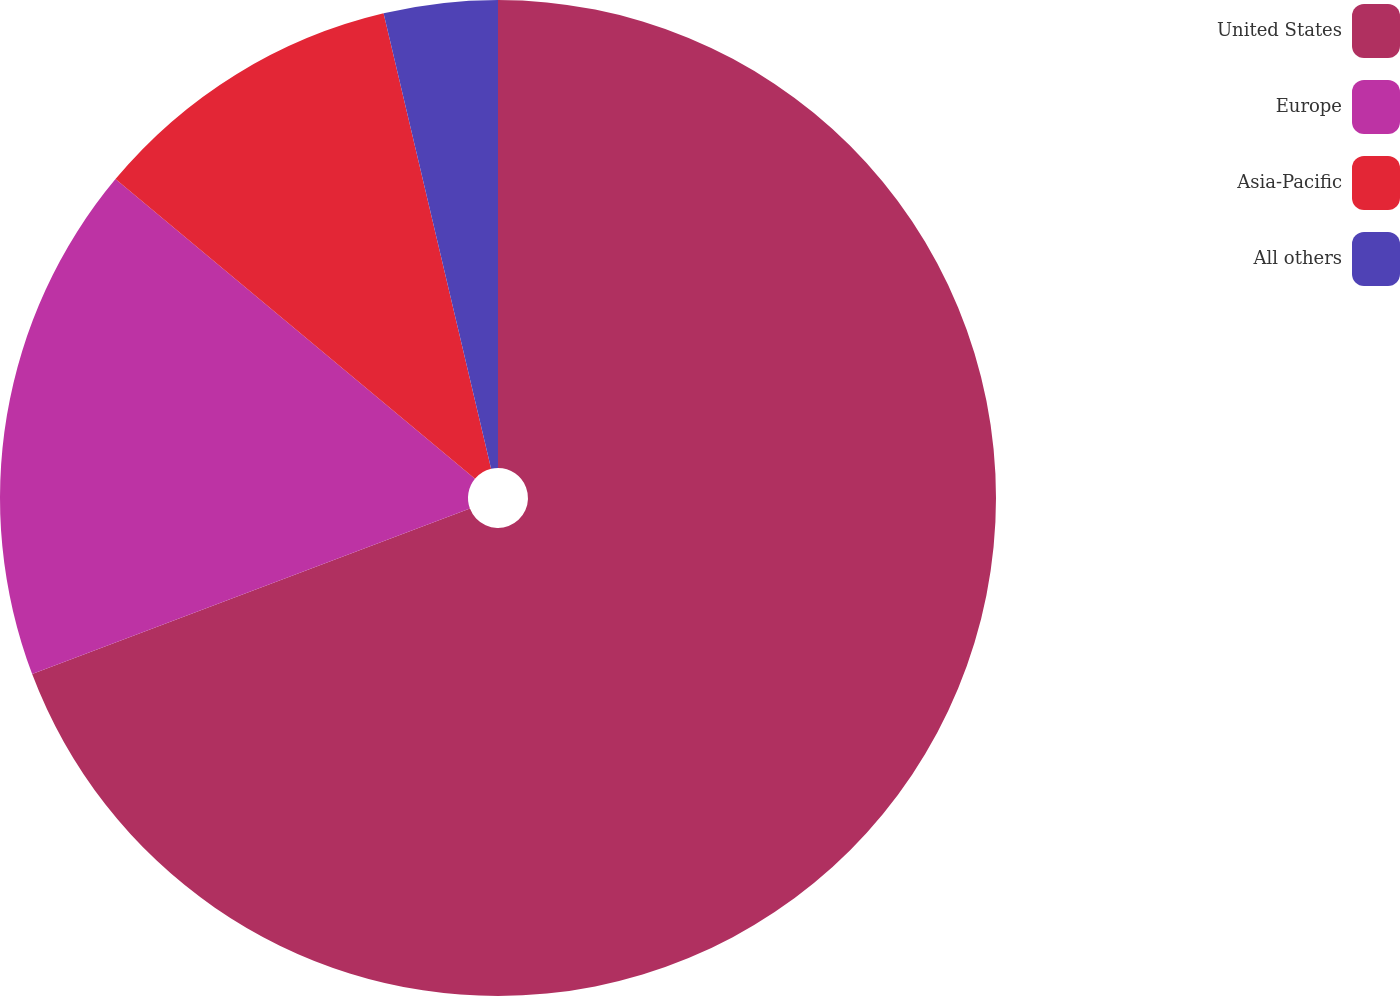<chart> <loc_0><loc_0><loc_500><loc_500><pie_chart><fcel>United States<fcel>Europe<fcel>Asia-Pacific<fcel>All others<nl><fcel>69.25%<fcel>16.81%<fcel>10.25%<fcel>3.69%<nl></chart> 